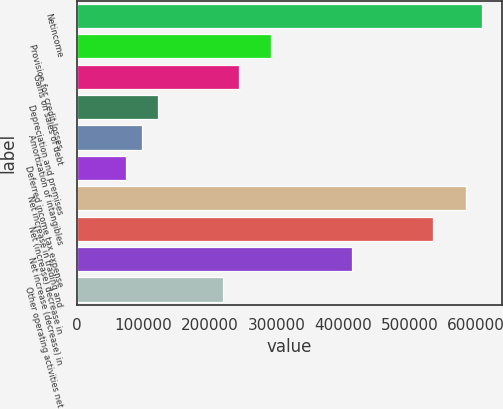Convert chart to OTSL. <chart><loc_0><loc_0><loc_500><loc_500><bar_chart><fcel>Netincome<fcel>Provision for credit losses<fcel>Gains on sales of debt<fcel>Depreciation and premises<fcel>Amortization of intangibles<fcel>Deferred income tax expense<fcel>Net increase in trading and<fcel>Net (increase) decrease in<fcel>Net increase (decrease) in<fcel>Other operating activities net<nl><fcel>608836<fcel>292275<fcel>243573<fcel>121818<fcel>97467.6<fcel>73116.7<fcel>584486<fcel>535784<fcel>414029<fcel>219222<nl></chart> 